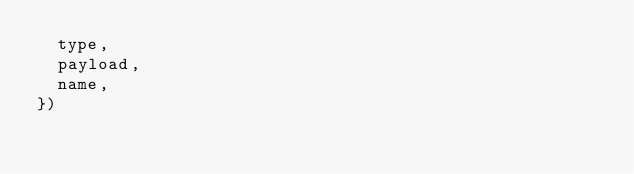Convert code to text. <code><loc_0><loc_0><loc_500><loc_500><_JavaScript_>  type,
  payload,
  name,
})
</code> 